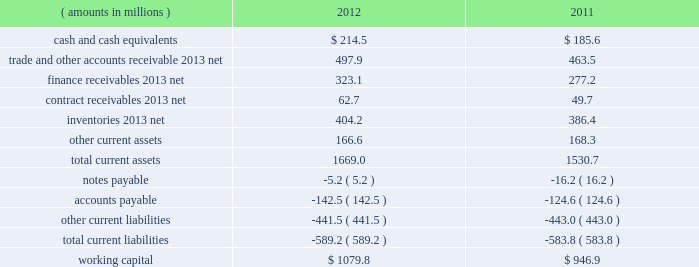Management 2019s discussion and analysis of financial condition and results of operations ( continued ) liquidity and capital resources snap-on 2019s growth has historically been funded by a combination of cash provided by operating activities and debt financing .
Snap-on believes that its cash from operations and collections of finance receivables , coupled with its sources of borrowings and available cash on hand , are sufficient to fund its currently anticipated requirements for payments of interest and dividends , new loans originated by our financial services businesses , capital expenditures , working capital , restructuring activities , the funding of pension plans , and funding for additional share repurchases and acquisitions , if any .
Due to snap-on 2019s credit rating over the years , external funds have been available at an acceptable cost .
As of the close of business on february 8 , 2013 , snap-on 2019s long-term debt and commercial paper were rated , respectively , baa1 and p-2 by moody 2019s investors service ; a- and a-2 by standard & poor 2019s ; and a- and f2 by fitch ratings .
Snap-on believes that its current credit arrangements are sound and that the strength of its balance sheet affords the company the financial flexibility to respond to both internal growth opportunities and those available through acquisitions .
However , snap-on cannot provide any assurances of the availability of future financing or the terms on which it might be available , or that its debt ratings may not decrease .
The following discussion focuses on information included in the accompanying consolidated balance sheets .
As of 2012 year end , working capital ( current assets less current liabilities ) of $ 1079.8 million increased $ 132.9 million from $ 946.9 million at 2011 year end .
The following represents the company 2019s working capital position as of 2012 and 2011 year end : ( amounts in millions ) 2012 2011 .
Cash and cash equivalents of $ 214.5 million as of 2012 year end compared to cash and cash equivalents of $ 185.6 million at 2011 year end .
The $ 28.9 million increase in cash and cash equivalents includes the impacts of ( i ) $ 329.3 million of cash generated from operations , net of $ 73.0 million of cash contributions ( including $ 54.7 million of discretionary contributions ) to the company 2019s domestic pension plans ; ( ii ) $ 445.5 million of cash from collections of finance receivables ; ( iii ) $ 46.8 million of proceeds from stock purchase and option plan exercises ; and ( iv ) $ 27.0 million of cash proceeds from the sale of a non-strategic equity investment at book value .
These increases in cash and cash equivalents were partially offset by ( i ) the funding of $ 569.6 million of new finance originations ; ( ii ) dividend payments of $ 81.5 million ; ( iii ) the funding of $ 79.4 million of capital expenditures ; and ( iv ) the repurchase of 1180000 shares of the company 2019s common stock for $ 78.1 million .
Of the $ 214.5 million of cash and cash equivalents as of 2012 year end , $ 81.4 million was held outside of the united states .
Snap-on considers these non-u.s .
Funds as permanently invested in its foreign operations to ( i ) provide adequate working capital ; ( ii ) satisfy various regulatory requirements ; and/or ( iii ) take advantage of business expansion opportunities as they arise ; as such , the company does not presently expect to repatriate these funds to fund its u.s .
Operations or obligations .
The repatriation of cash from certain foreign subsidiaries could have adverse net tax consequences on the company should snap-on be required to pay and record u.s .
Income taxes and foreign withholding taxes on funds that were previously considered permanently invested .
Alternatively , the repatriation of such cash from certain other foreign subsidiaries could result in favorable net tax consequences for the company .
Snap-on periodically evaluates opportunities to repatriate certain foreign cash amounts to the extent that it does not incur additional unfavorable net tax consequences .
44 snap-on incorporated .
What portion of cash and cash equivalents as of 2012 was held outside unites states? 
Computations: (81.4 / 214.5)
Answer: 0.37949. 